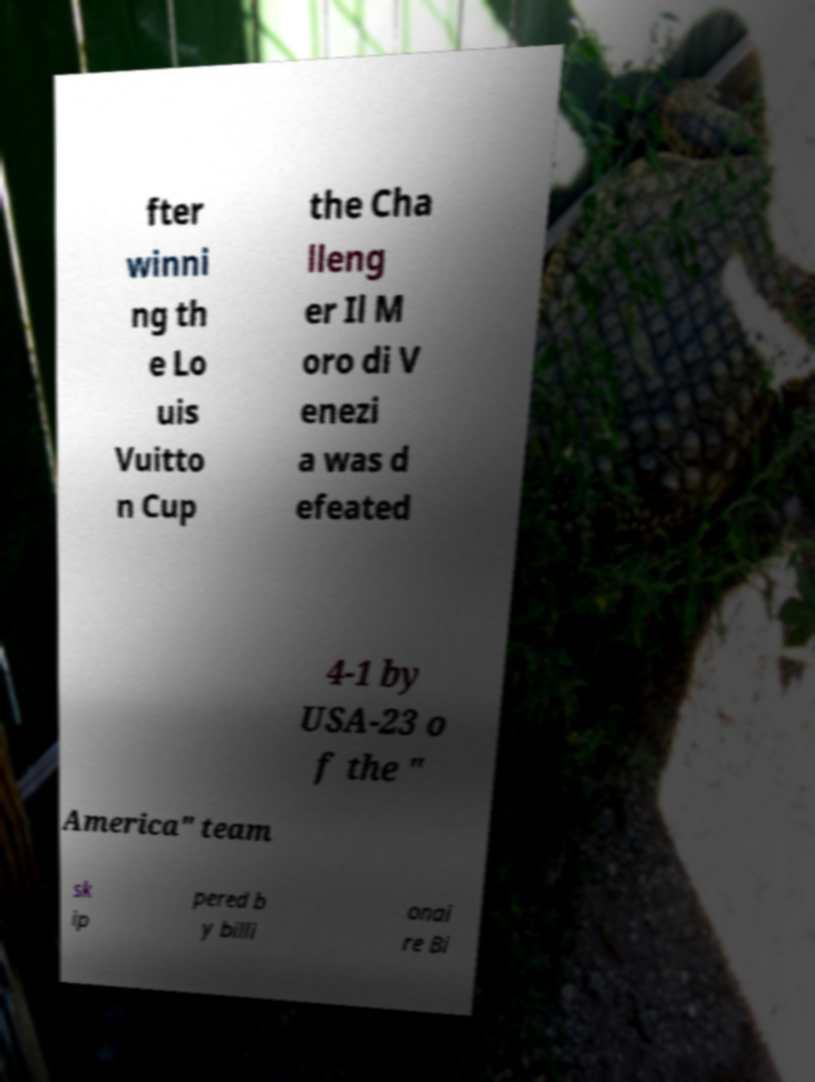Please identify and transcribe the text found in this image. fter winni ng th e Lo uis Vuitto n Cup the Cha lleng er Il M oro di V enezi a was d efeated 4-1 by USA-23 o f the " America" team sk ip pered b y billi onai re Bi 